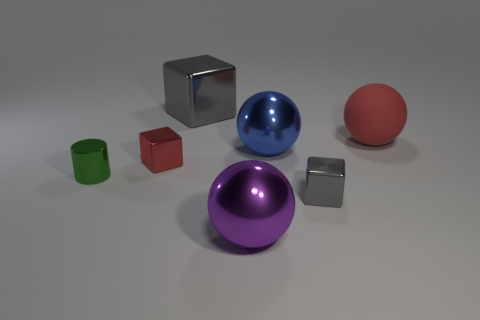How many gray cubes must be subtracted to get 1 gray cubes? 1 Subtract all spheres. How many objects are left? 4 Subtract 1 cylinders. How many cylinders are left? 0 Subtract all gray balls. Subtract all red blocks. How many balls are left? 3 Subtract all purple spheres. How many gray cubes are left? 2 Subtract all large cyan blocks. Subtract all tiny red things. How many objects are left? 6 Add 7 small objects. How many small objects are left? 10 Add 6 gray rubber cubes. How many gray rubber cubes exist? 6 Add 3 green metallic cylinders. How many objects exist? 10 Subtract all gray blocks. How many blocks are left? 1 